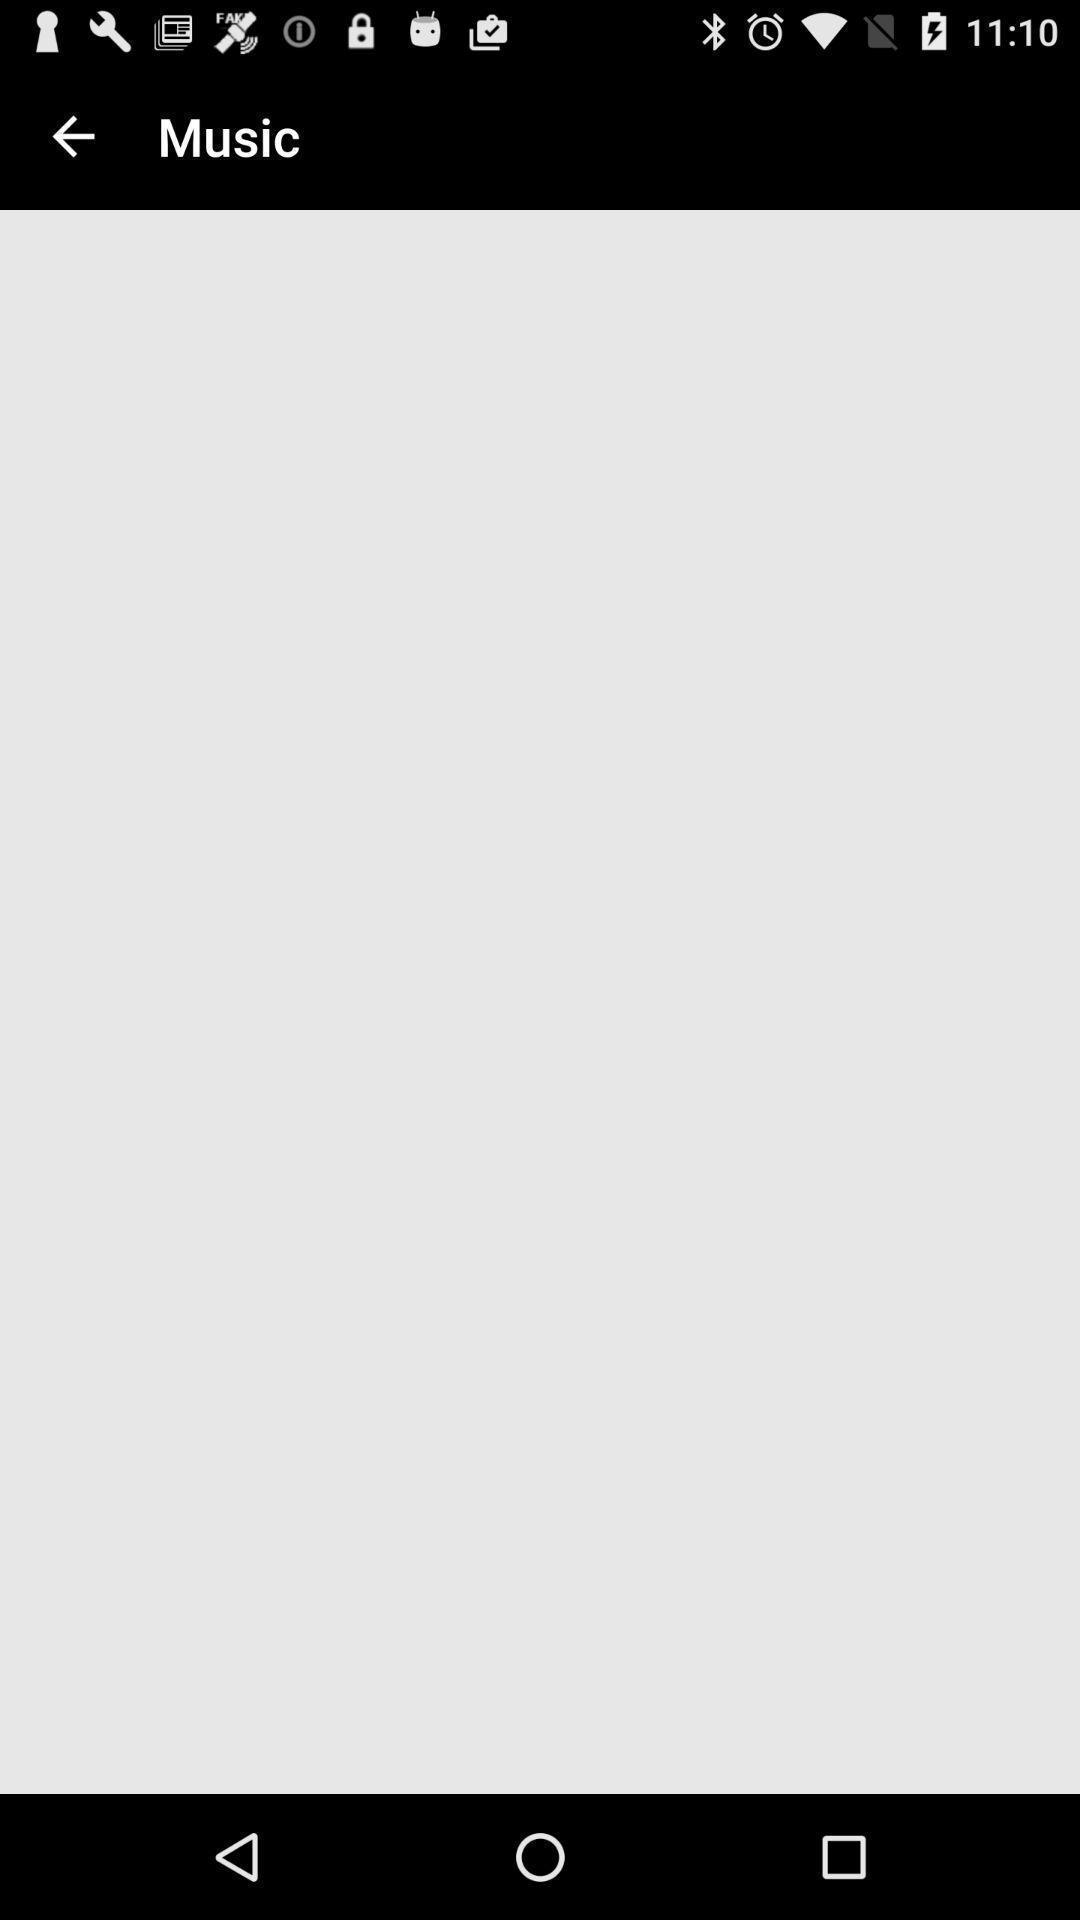Provide a detailed account of this screenshot. Screen displaying the music page which is empty. 